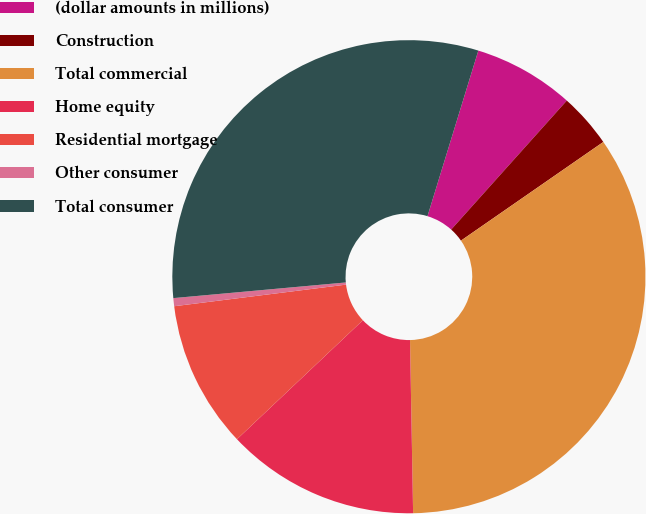Convert chart. <chart><loc_0><loc_0><loc_500><loc_500><pie_chart><fcel>(dollar amounts in millions)<fcel>Construction<fcel>Total commercial<fcel>Home equity<fcel>Residential mortgage<fcel>Other consumer<fcel>Total consumer<nl><fcel>6.89%<fcel>3.72%<fcel>34.36%<fcel>13.23%<fcel>10.06%<fcel>0.55%<fcel>31.18%<nl></chart> 